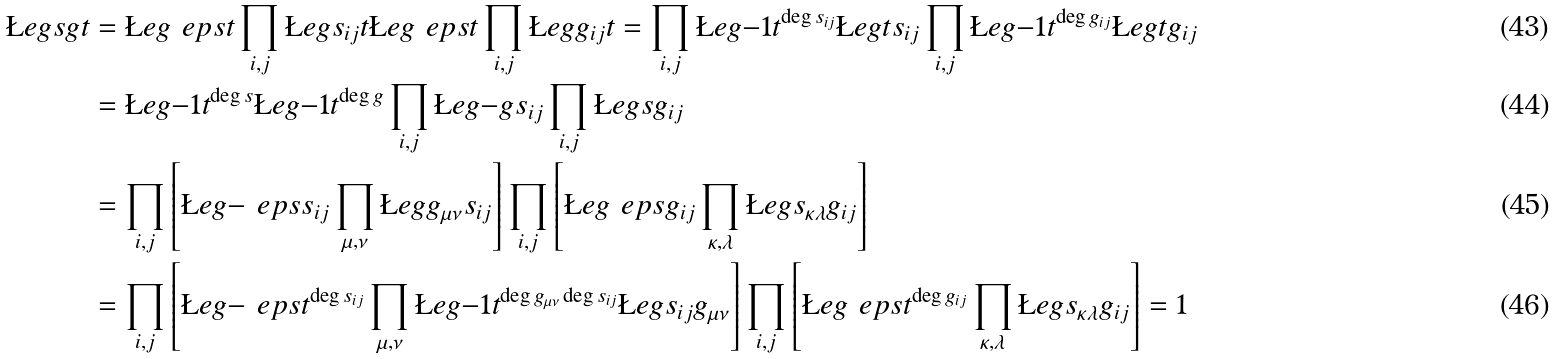<formula> <loc_0><loc_0><loc_500><loc_500>\L e g { s g } { t } & = \L e g { \ e p s } { t } \prod _ { i , j } \L e g { s _ { i j } } { t } \L e g { \ e p s } { t } \prod _ { i , j } \L e g { g _ { i j } } { t } = \prod _ { i , j } \L e g { - 1 } { t } ^ { \deg s _ { i j } } \L e g { t } { s _ { i j } } \prod _ { i , j } \L e g { - 1 } { t } ^ { \deg g _ { i j } } \L e g { t } { g _ { i j } } \\ & = \L e g { - 1 } { t } ^ { \deg s } \L e g { - 1 } { t } ^ { \deg g } \prod _ { i , j } \L e g { - g } { s _ { i j } } \prod _ { i , j } \L e g { s } { g _ { i j } } \\ & = \prod _ { i , j } \left [ \L e g { - \ e p s } { s _ { i j } } \prod _ { \mu , \nu } \L e g { g _ { \mu \nu } } { s _ { i j } } \right ] \prod _ { i , j } \left [ \L e g { \ e p s } { g _ { i j } } \prod _ { \kappa , \lambda } \L e g { s _ { \kappa \lambda } } { g _ { i j } } \right ] \\ & = \prod _ { i , j } \left [ \L e g { - \ e p s } { t } ^ { \deg s _ { i j } } \prod _ { \mu , \nu } \L e g { - 1 } { t } ^ { \deg g _ { \mu \nu } \deg s _ { i j } } \L e g { s _ { i j } } { g _ { \mu \nu } } \right ] \prod _ { i , j } \left [ \L e g { \ e p s } { t } ^ { \deg g _ { i j } } \prod _ { \kappa , \lambda } \L e g { s _ { \kappa \lambda } } { g _ { i j } } \right ] = 1</formula> 